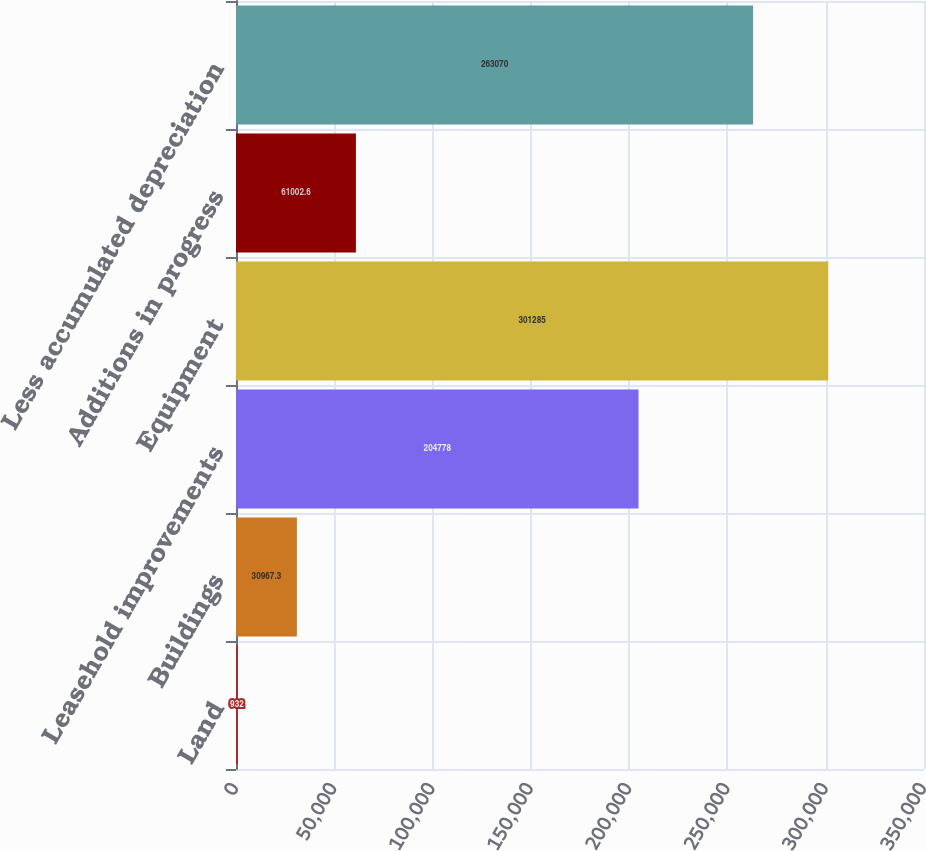Convert chart to OTSL. <chart><loc_0><loc_0><loc_500><loc_500><bar_chart><fcel>Land<fcel>Buildings<fcel>Leasehold improvements<fcel>Equipment<fcel>Additions in progress<fcel>Less accumulated depreciation<nl><fcel>932<fcel>30967.3<fcel>204778<fcel>301285<fcel>61002.6<fcel>263070<nl></chart> 